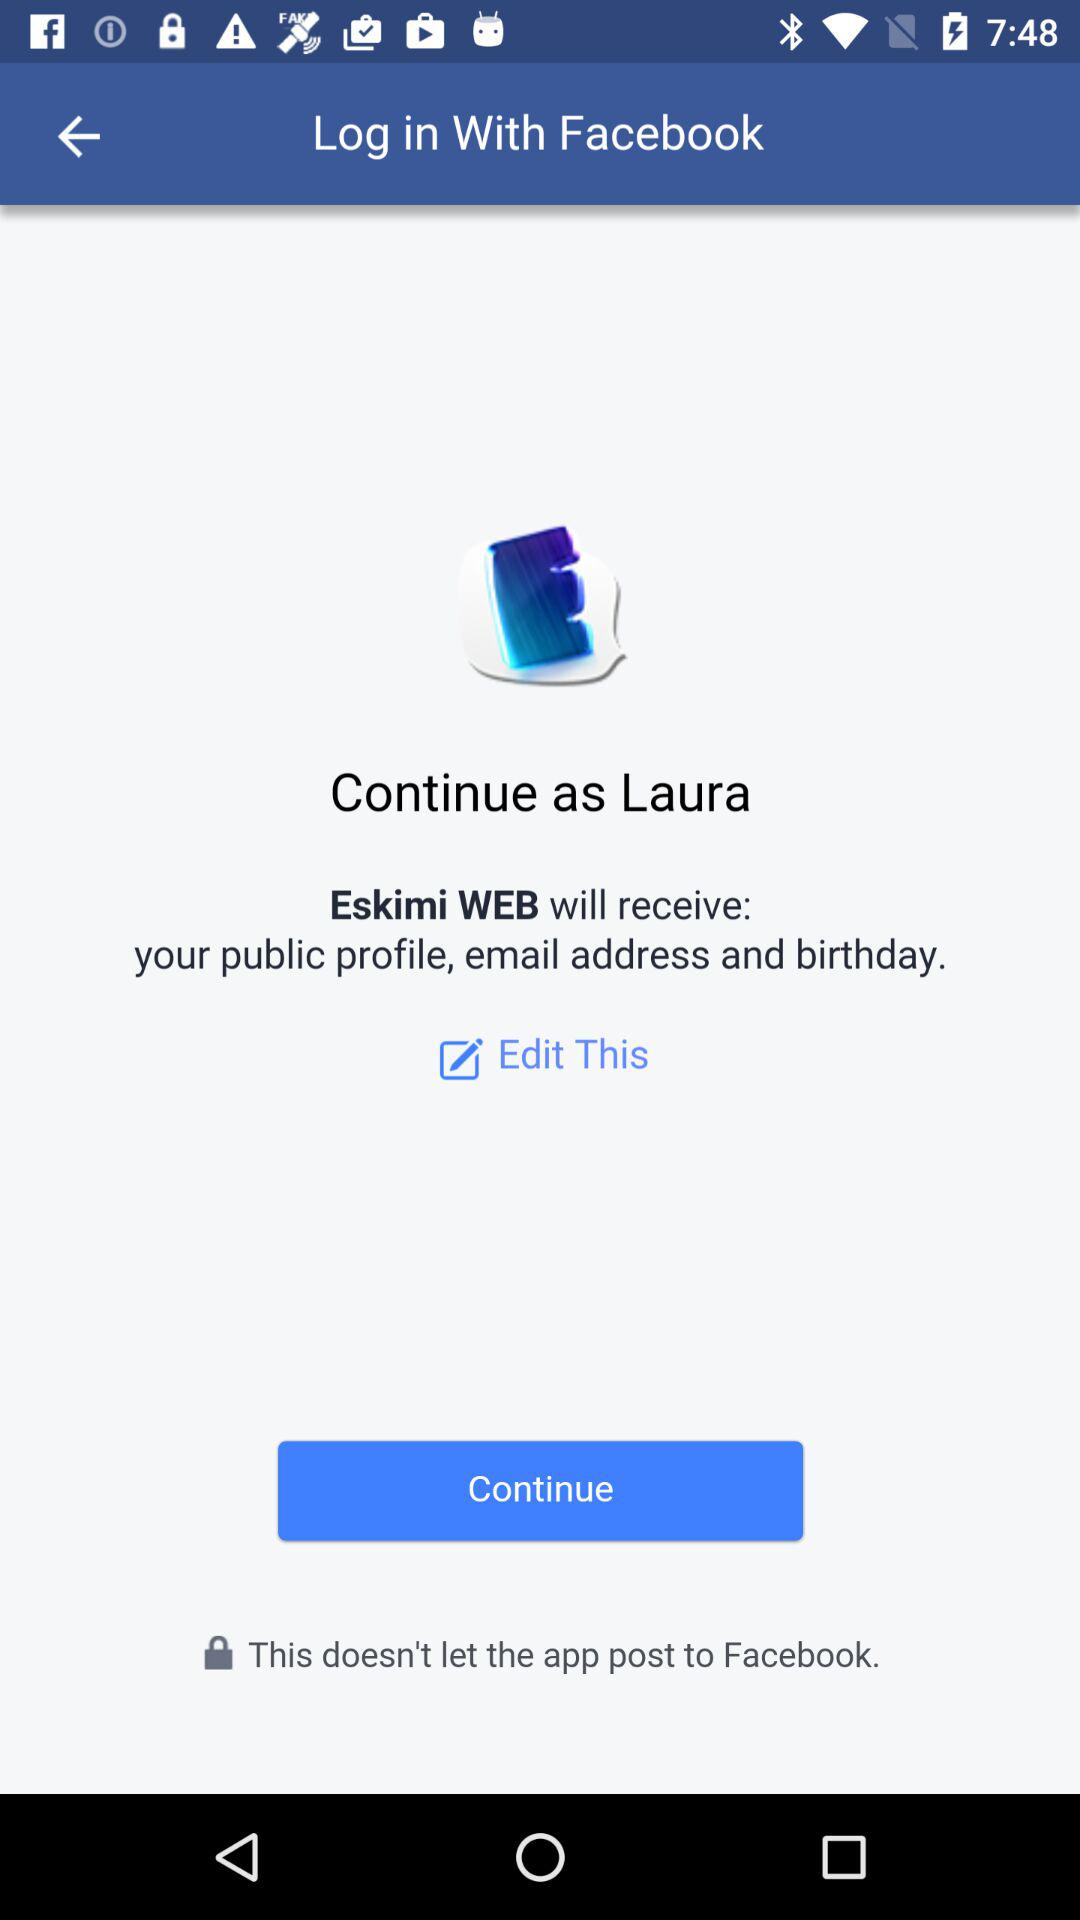Which application will receive my public profile, email address and birthday? The application "Eskimi WEB" will receive your public profile, email address and birthday. 